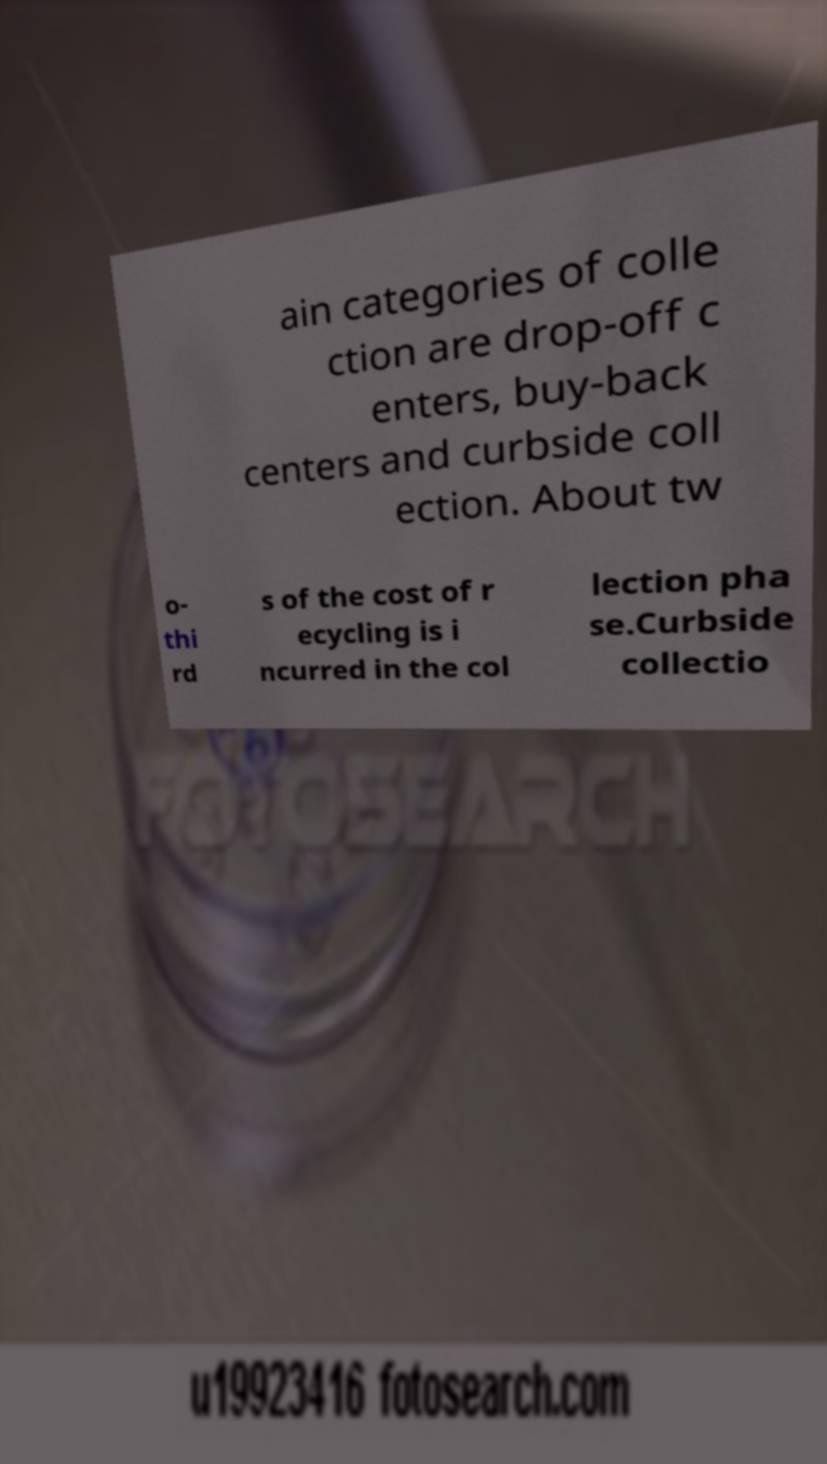For documentation purposes, I need the text within this image transcribed. Could you provide that? ain categories of colle ction are drop-off c enters, buy-back centers and curbside coll ection. About tw o- thi rd s of the cost of r ecycling is i ncurred in the col lection pha se.Curbside collectio 